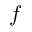Convert formula to latex. <formula><loc_0><loc_0><loc_500><loc_500>f</formula> 